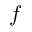Convert formula to latex. <formula><loc_0><loc_0><loc_500><loc_500>f</formula> 